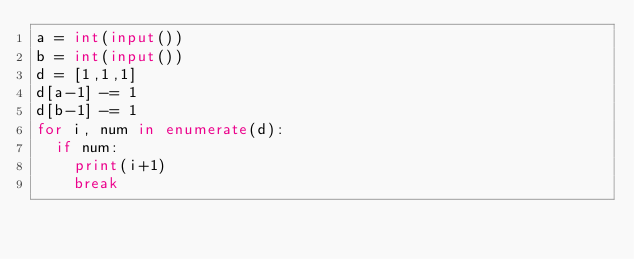Convert code to text. <code><loc_0><loc_0><loc_500><loc_500><_Python_>a = int(input())
b = int(input())
d = [1,1,1]
d[a-1] -= 1
d[b-1] -= 1
for i, num in enumerate(d):
  if num:
    print(i+1)
    break</code> 